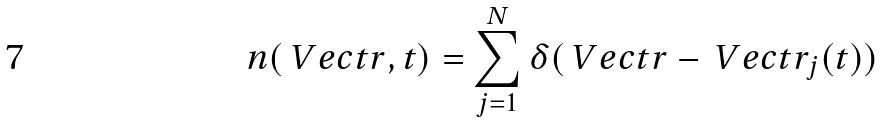Convert formula to latex. <formula><loc_0><loc_0><loc_500><loc_500>n ( \ V e c t { r } , t ) = \sum _ { j = 1 } ^ { N } \delta ( \ V e c t { r } - \ V e c t { r } _ { j } ( t ) )</formula> 